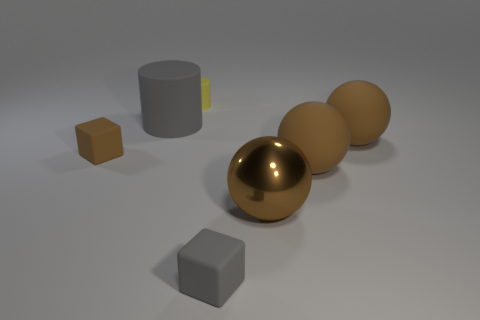What materials do the objects in the image seem to be made of? The cylinder appears to have a smooth, possibly metallic surface, while the spheres have a matte, rubber-like appearance. The cubes could be envisioned as either plastic or metallic, based on their sharp edges and solid colors. 